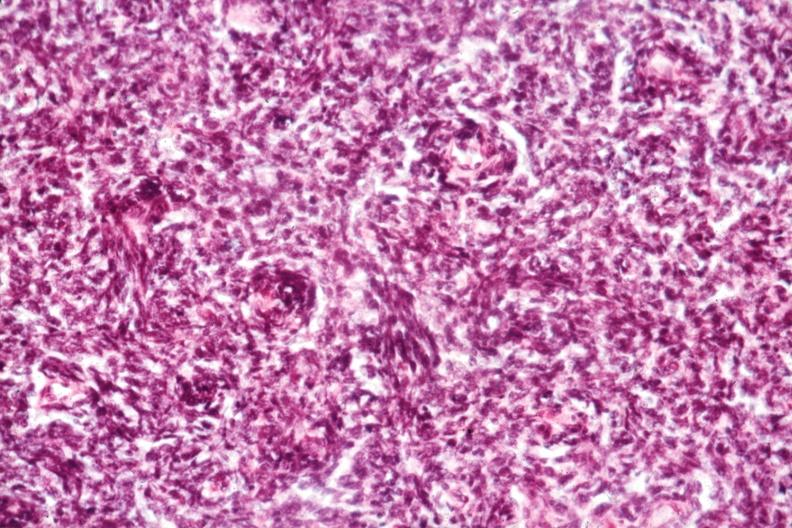s this photo of infant from head to toe present?
Answer the question using a single word or phrase. No 